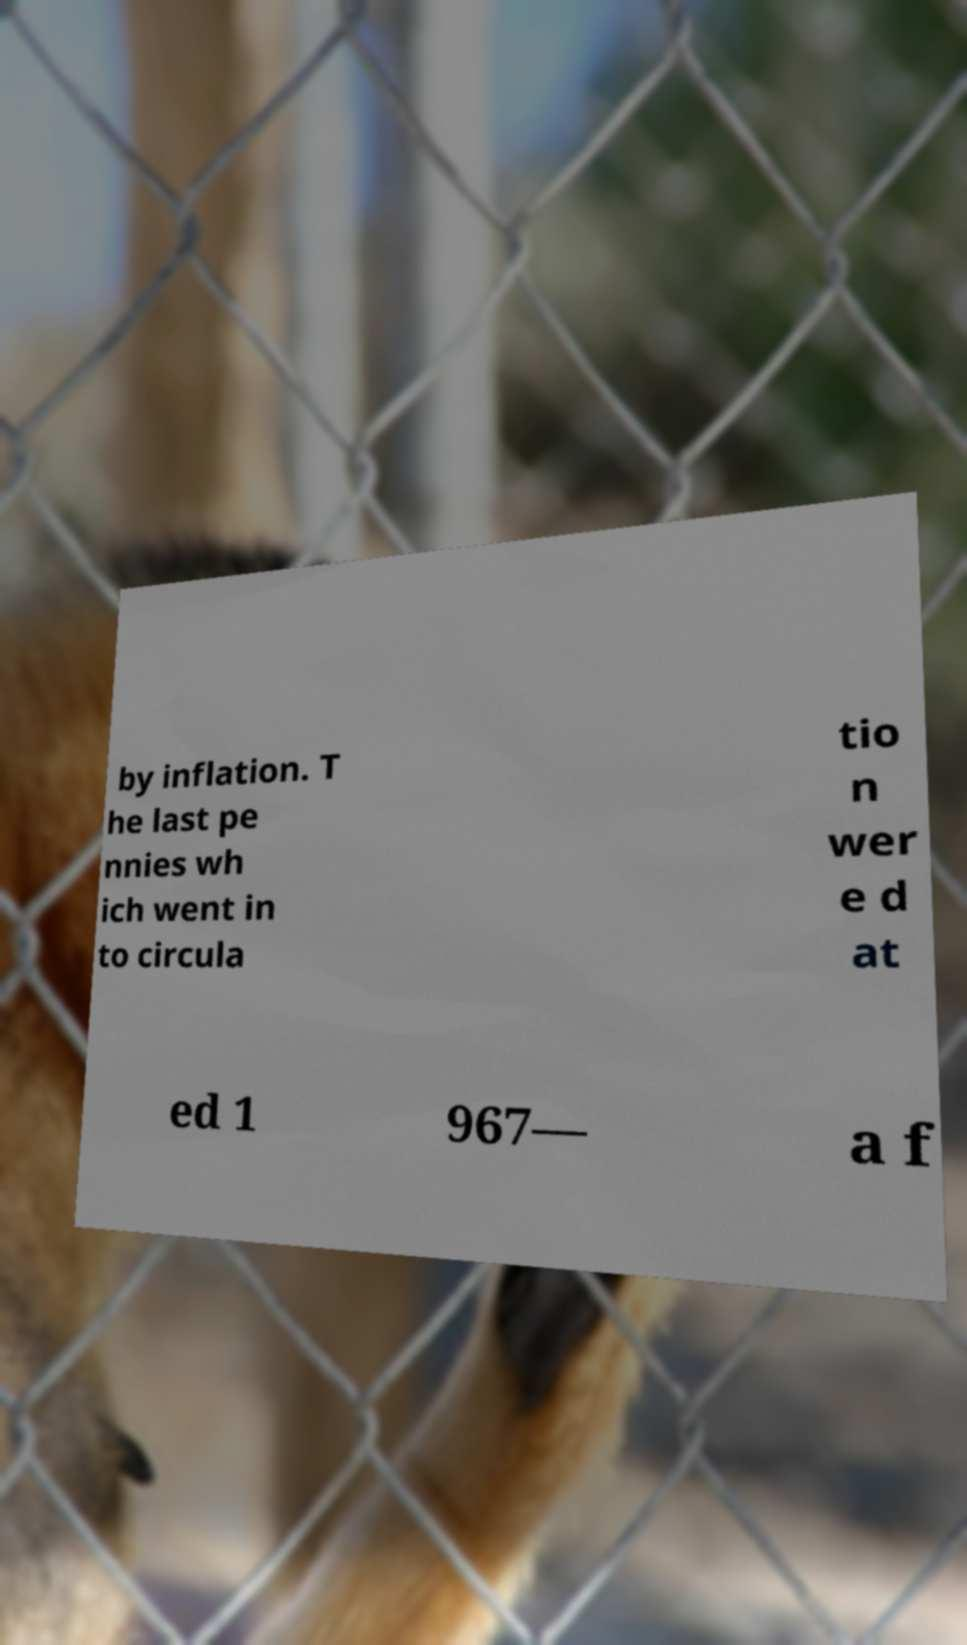For documentation purposes, I need the text within this image transcribed. Could you provide that? by inflation. T he last pe nnies wh ich went in to circula tio n wer e d at ed 1 967— a f 